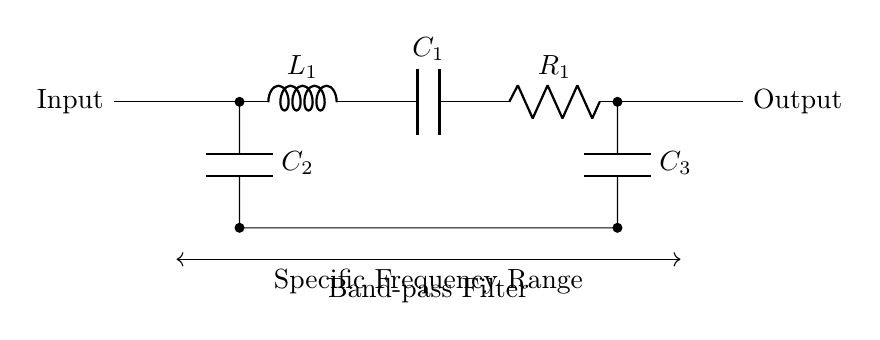What are the components in this circuit? The circuit contains two inductors (L), three capacitors (C), and one resistor (R). Each component is labeled, allowing identification.
Answer: Inductor, Capacitor, Resistor What is the role of the inductor in this band-pass filter? The inductor allows alternating current to pass while blocking direct current, contributing to the filtering of specific frequency ranges by introducing a reactive impedance.
Answer: Filter specific frequencies What does the label "C2" represent? "C2" indicates a capacitor in the circuit schematic, which is used to couple or decouple AC signals while blocking DC signals.
Answer: Capacitor C2 How many capacitors are present in this filter circuit? The diagram shows three capacitors labeled as C1, C2, and C3. Counting these in the diagram confirms the quantity.
Answer: Three What frequency range does this band-pass filter isolate? The circuit is designed to isolate a specific frequency range, indicated explicitly at the bottom of the diagram. Generally, this refers to a target band of frequencies, but the exact range would be defined by component values.
Answer: Specific Frequency Range Which component is placed last in the signal path? The last component in the signal path before the output node is the capacitor C3, which is connected parallel to the output.
Answer: Capacitor C3 What is the purpose of the resistor R1 in this circuit? The resistor R1 helps to set the gain or the attenuation of the signals passing through the filter, affecting the overall frequency response. By integrating R1 with the capacitors and inductors, it helps to achieve the desired filter characteristics.
Answer: Set gain or attenuation 